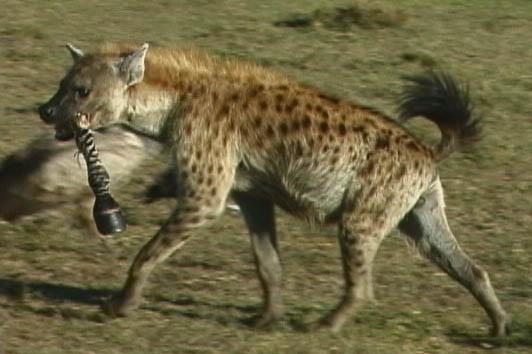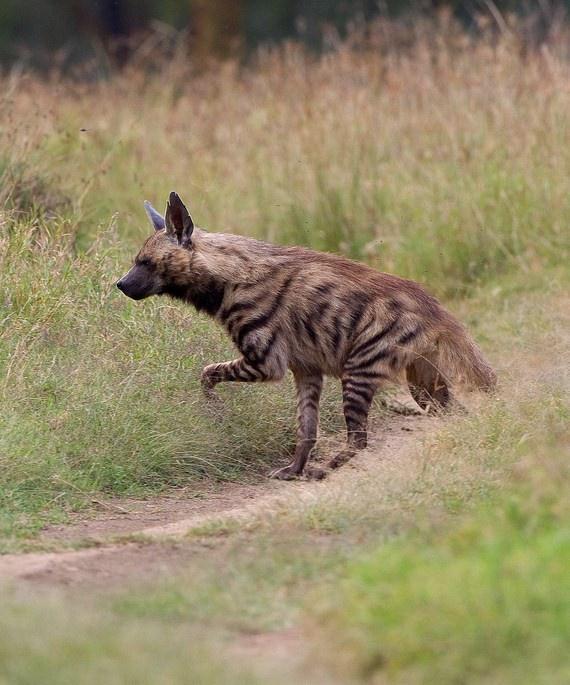The first image is the image on the left, the second image is the image on the right. For the images displayed, is the sentence "There is at least one animal carrying another animal or part of another animal." factually correct? Answer yes or no. Yes. The first image is the image on the left, the second image is the image on the right. Analyze the images presented: Is the assertion "There is a hyena carrying prey in its mouth." valid? Answer yes or no. Yes. 